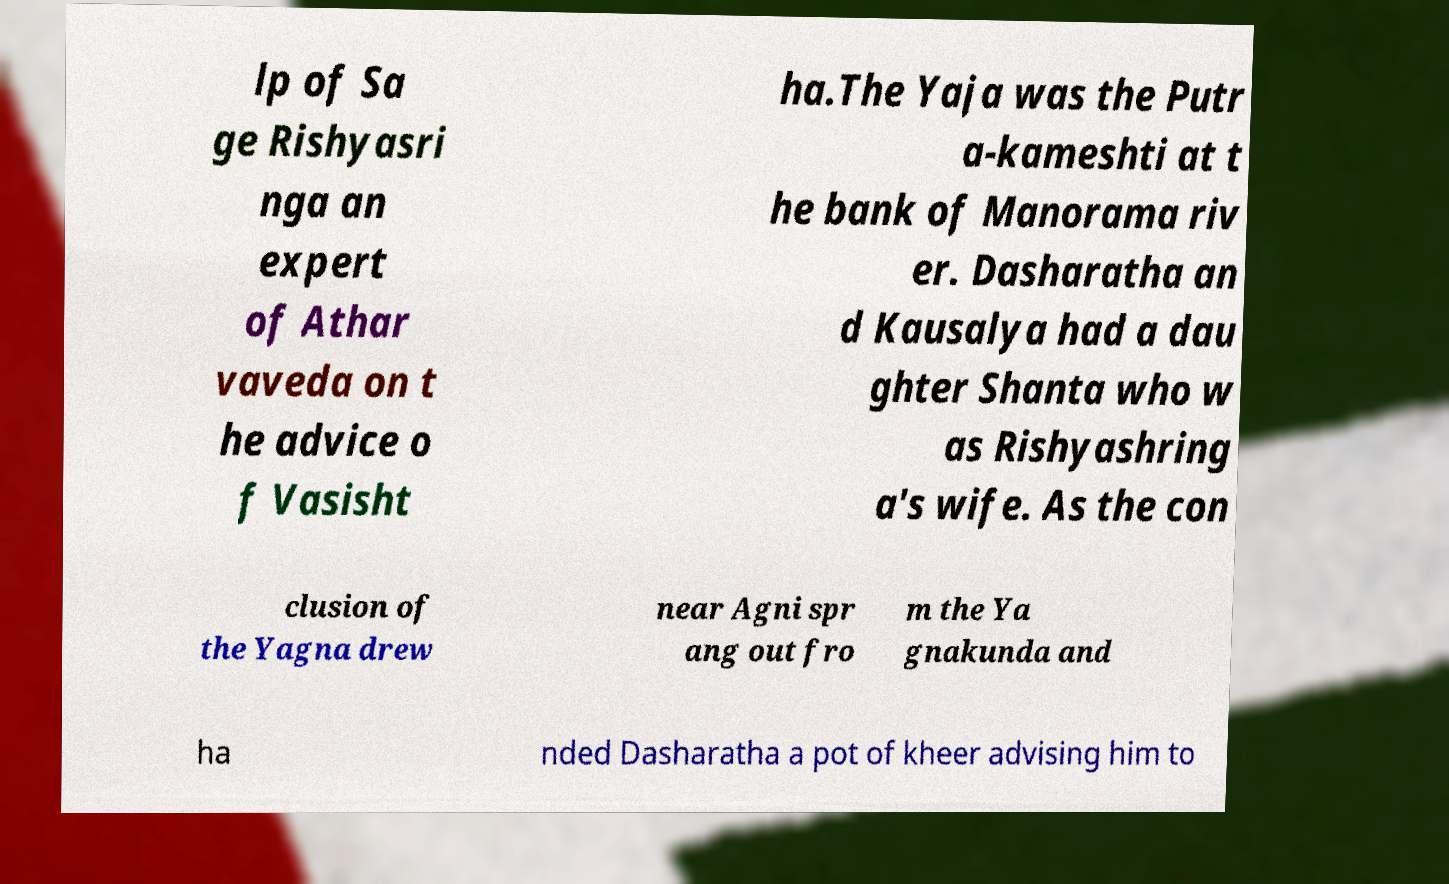Could you extract and type out the text from this image? lp of Sa ge Rishyasri nga an expert of Athar vaveda on t he advice o f Vasisht ha.The Yaja was the Putr a-kameshti at t he bank of Manorama riv er. Dasharatha an d Kausalya had a dau ghter Shanta who w as Rishyashring a's wife. As the con clusion of the Yagna drew near Agni spr ang out fro m the Ya gnakunda and ha nded Dasharatha a pot of kheer advising him to 